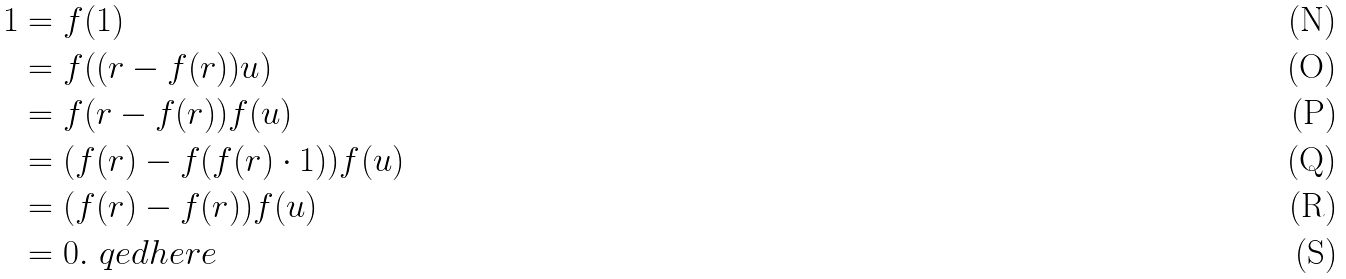<formula> <loc_0><loc_0><loc_500><loc_500>1 & = f ( 1 ) \\ & = f ( ( r - f ( r ) ) u ) \\ & = f ( r - f ( r ) ) f ( u ) \\ & = ( f ( r ) - f ( f ( r ) \cdot 1 ) ) f ( u ) \\ & = ( f ( r ) - f ( r ) ) f ( u ) \\ & = 0 . \ q e d h e r e</formula> 